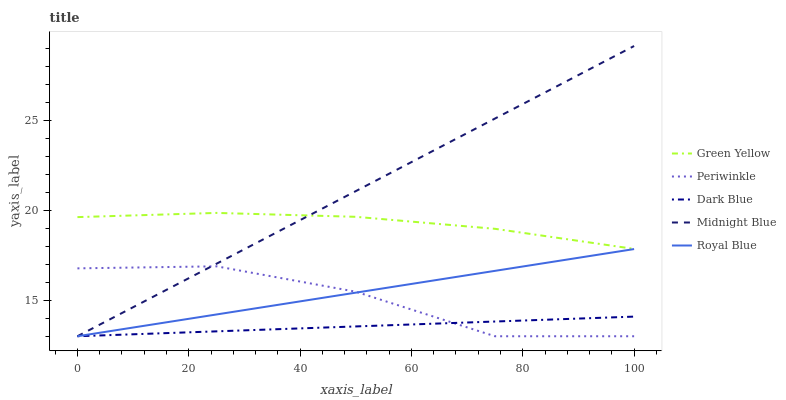Does Dark Blue have the minimum area under the curve?
Answer yes or no. Yes. Does Midnight Blue have the maximum area under the curve?
Answer yes or no. Yes. Does Green Yellow have the minimum area under the curve?
Answer yes or no. No. Does Green Yellow have the maximum area under the curve?
Answer yes or no. No. Is Dark Blue the smoothest?
Answer yes or no. Yes. Is Periwinkle the roughest?
Answer yes or no. Yes. Is Green Yellow the smoothest?
Answer yes or no. No. Is Green Yellow the roughest?
Answer yes or no. No. Does Dark Blue have the lowest value?
Answer yes or no. Yes. Does Green Yellow have the lowest value?
Answer yes or no. No. Does Midnight Blue have the highest value?
Answer yes or no. Yes. Does Green Yellow have the highest value?
Answer yes or no. No. Is Dark Blue less than Green Yellow?
Answer yes or no. Yes. Is Green Yellow greater than Royal Blue?
Answer yes or no. Yes. Does Royal Blue intersect Periwinkle?
Answer yes or no. Yes. Is Royal Blue less than Periwinkle?
Answer yes or no. No. Is Royal Blue greater than Periwinkle?
Answer yes or no. No. Does Dark Blue intersect Green Yellow?
Answer yes or no. No. 